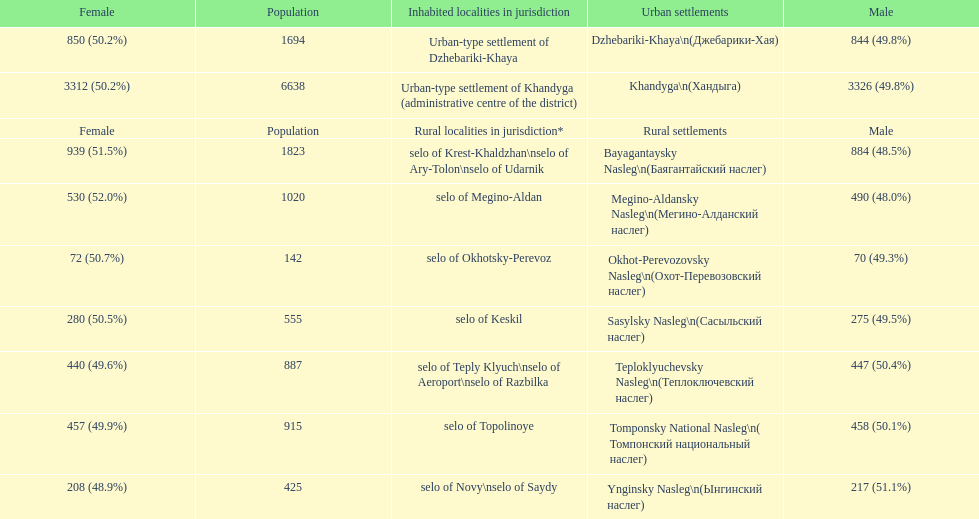Which rural settlement has the most males in their population? Bayagantaysky Nasleg (Áàÿãàíòàéñêèé íàñëåã). 